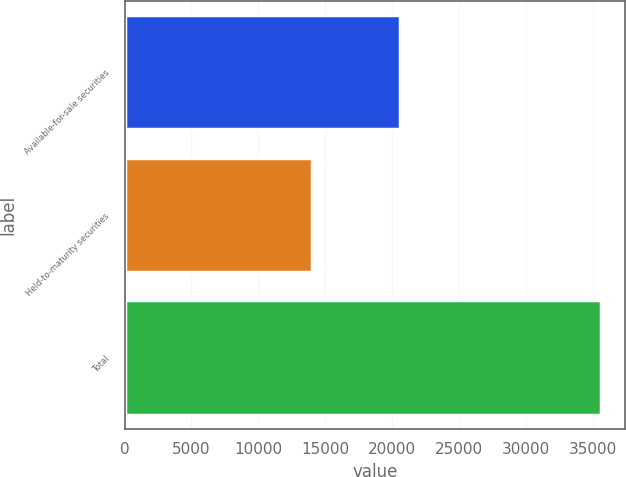<chart> <loc_0><loc_0><loc_500><loc_500><bar_chart><fcel>Available-for-sale securities<fcel>Held-to-maturity securities<fcel>Total<nl><fcel>20620<fcel>14009<fcel>35645<nl></chart> 